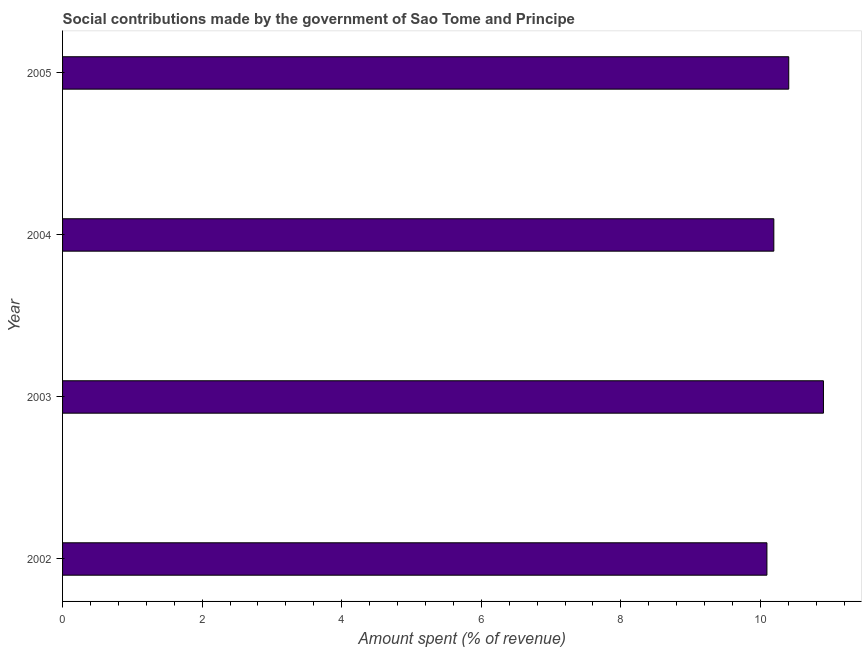Does the graph contain any zero values?
Give a very brief answer. No. Does the graph contain grids?
Offer a terse response. No. What is the title of the graph?
Offer a very short reply. Social contributions made by the government of Sao Tome and Principe. What is the label or title of the X-axis?
Offer a terse response. Amount spent (% of revenue). What is the label or title of the Y-axis?
Offer a very short reply. Year. What is the amount spent in making social contributions in 2005?
Make the answer very short. 10.41. Across all years, what is the maximum amount spent in making social contributions?
Provide a short and direct response. 10.9. Across all years, what is the minimum amount spent in making social contributions?
Give a very brief answer. 10.09. In which year was the amount spent in making social contributions maximum?
Your answer should be very brief. 2003. What is the sum of the amount spent in making social contributions?
Your response must be concise. 41.6. What is the difference between the amount spent in making social contributions in 2003 and 2005?
Offer a very short reply. 0.5. What is the average amount spent in making social contributions per year?
Your answer should be very brief. 10.4. What is the median amount spent in making social contributions?
Provide a succinct answer. 10.3. In how many years, is the amount spent in making social contributions greater than 4.8 %?
Your answer should be very brief. 4. What is the difference between the highest and the second highest amount spent in making social contributions?
Give a very brief answer. 0.5. Is the sum of the amount spent in making social contributions in 2004 and 2005 greater than the maximum amount spent in making social contributions across all years?
Your answer should be compact. Yes. What is the difference between the highest and the lowest amount spent in making social contributions?
Give a very brief answer. 0.81. Are all the bars in the graph horizontal?
Provide a succinct answer. Yes. What is the difference between two consecutive major ticks on the X-axis?
Offer a very short reply. 2. What is the Amount spent (% of revenue) in 2002?
Your answer should be compact. 10.09. What is the Amount spent (% of revenue) in 2003?
Give a very brief answer. 10.9. What is the Amount spent (% of revenue) in 2004?
Offer a terse response. 10.19. What is the Amount spent (% of revenue) in 2005?
Offer a very short reply. 10.41. What is the difference between the Amount spent (% of revenue) in 2002 and 2003?
Offer a terse response. -0.81. What is the difference between the Amount spent (% of revenue) in 2002 and 2004?
Keep it short and to the point. -0.1. What is the difference between the Amount spent (% of revenue) in 2002 and 2005?
Give a very brief answer. -0.31. What is the difference between the Amount spent (% of revenue) in 2003 and 2004?
Keep it short and to the point. 0.71. What is the difference between the Amount spent (% of revenue) in 2003 and 2005?
Ensure brevity in your answer.  0.5. What is the difference between the Amount spent (% of revenue) in 2004 and 2005?
Offer a terse response. -0.21. What is the ratio of the Amount spent (% of revenue) in 2002 to that in 2003?
Offer a terse response. 0.93. What is the ratio of the Amount spent (% of revenue) in 2003 to that in 2004?
Offer a terse response. 1.07. What is the ratio of the Amount spent (% of revenue) in 2003 to that in 2005?
Your answer should be very brief. 1.05. What is the ratio of the Amount spent (% of revenue) in 2004 to that in 2005?
Ensure brevity in your answer.  0.98. 